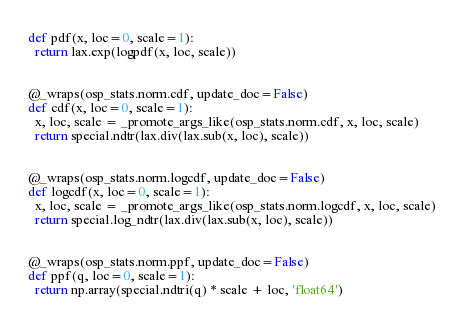<code> <loc_0><loc_0><loc_500><loc_500><_Python_>def pdf(x, loc=0, scale=1):
  return lax.exp(logpdf(x, loc, scale))


@_wraps(osp_stats.norm.cdf, update_doc=False)
def cdf(x, loc=0, scale=1):
  x, loc, scale = _promote_args_like(osp_stats.norm.cdf, x, loc, scale)
  return special.ndtr(lax.div(lax.sub(x, loc), scale))


@_wraps(osp_stats.norm.logcdf, update_doc=False)
def logcdf(x, loc=0, scale=1):
  x, loc, scale = _promote_args_like(osp_stats.norm.logcdf, x, loc, scale)
  return special.log_ndtr(lax.div(lax.sub(x, loc), scale))


@_wraps(osp_stats.norm.ppf, update_doc=False)
def ppf(q, loc=0, scale=1):
  return np.array(special.ndtri(q) * scale + loc, 'float64')</code> 